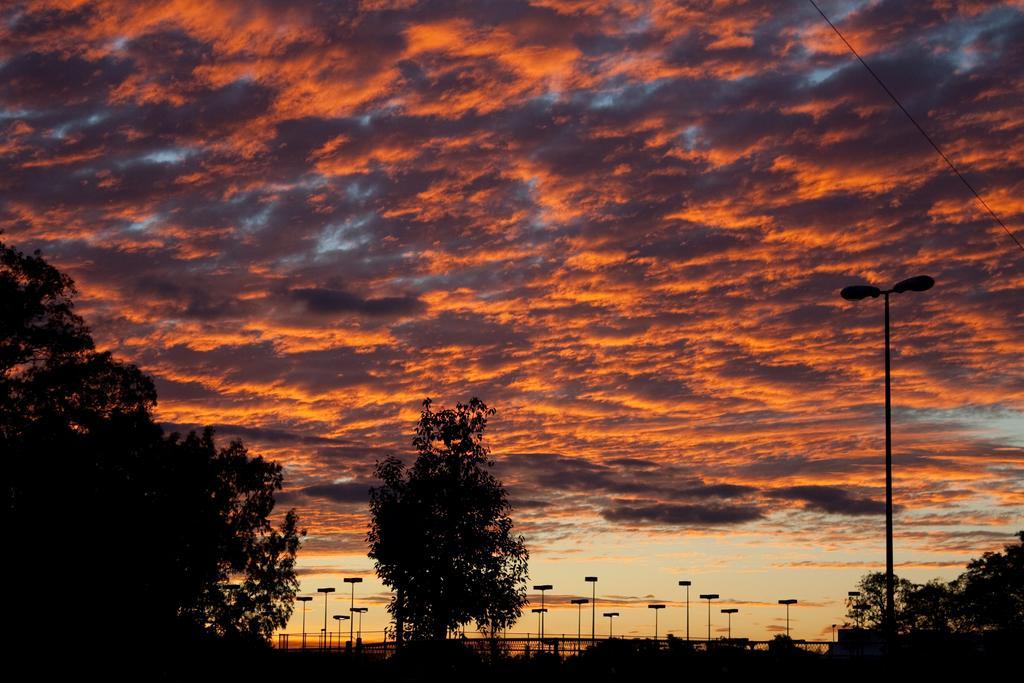Could you give a brief overview of what you see in this image? The picture is clicked during evening. In the foreground of the picture there are trees and street lights. Sky is cloudy. On the right there is a cable. 